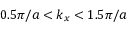<formula> <loc_0><loc_0><loc_500><loc_500>0 . 5 \pi / a < k _ { x } < 1 . 5 \pi / a</formula> 